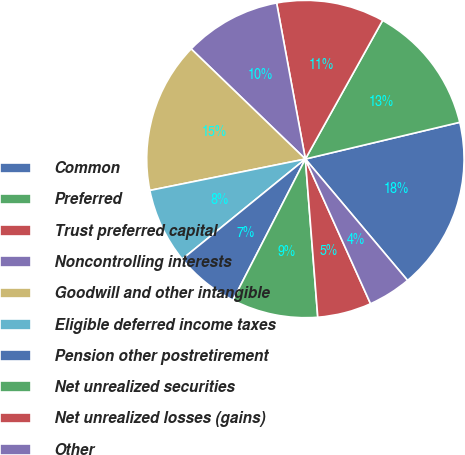Convert chart. <chart><loc_0><loc_0><loc_500><loc_500><pie_chart><fcel>Common<fcel>Preferred<fcel>Trust preferred capital<fcel>Noncontrolling interests<fcel>Goodwill and other intangible<fcel>Eligible deferred income taxes<fcel>Pension other postretirement<fcel>Net unrealized securities<fcel>Net unrealized losses (gains)<fcel>Other<nl><fcel>17.58%<fcel>13.19%<fcel>10.99%<fcel>9.89%<fcel>15.38%<fcel>7.69%<fcel>6.59%<fcel>8.79%<fcel>5.49%<fcel>4.4%<nl></chart> 